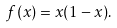Convert formula to latex. <formula><loc_0><loc_0><loc_500><loc_500>f ( x ) = { x } ( 1 - { x } ) .</formula> 